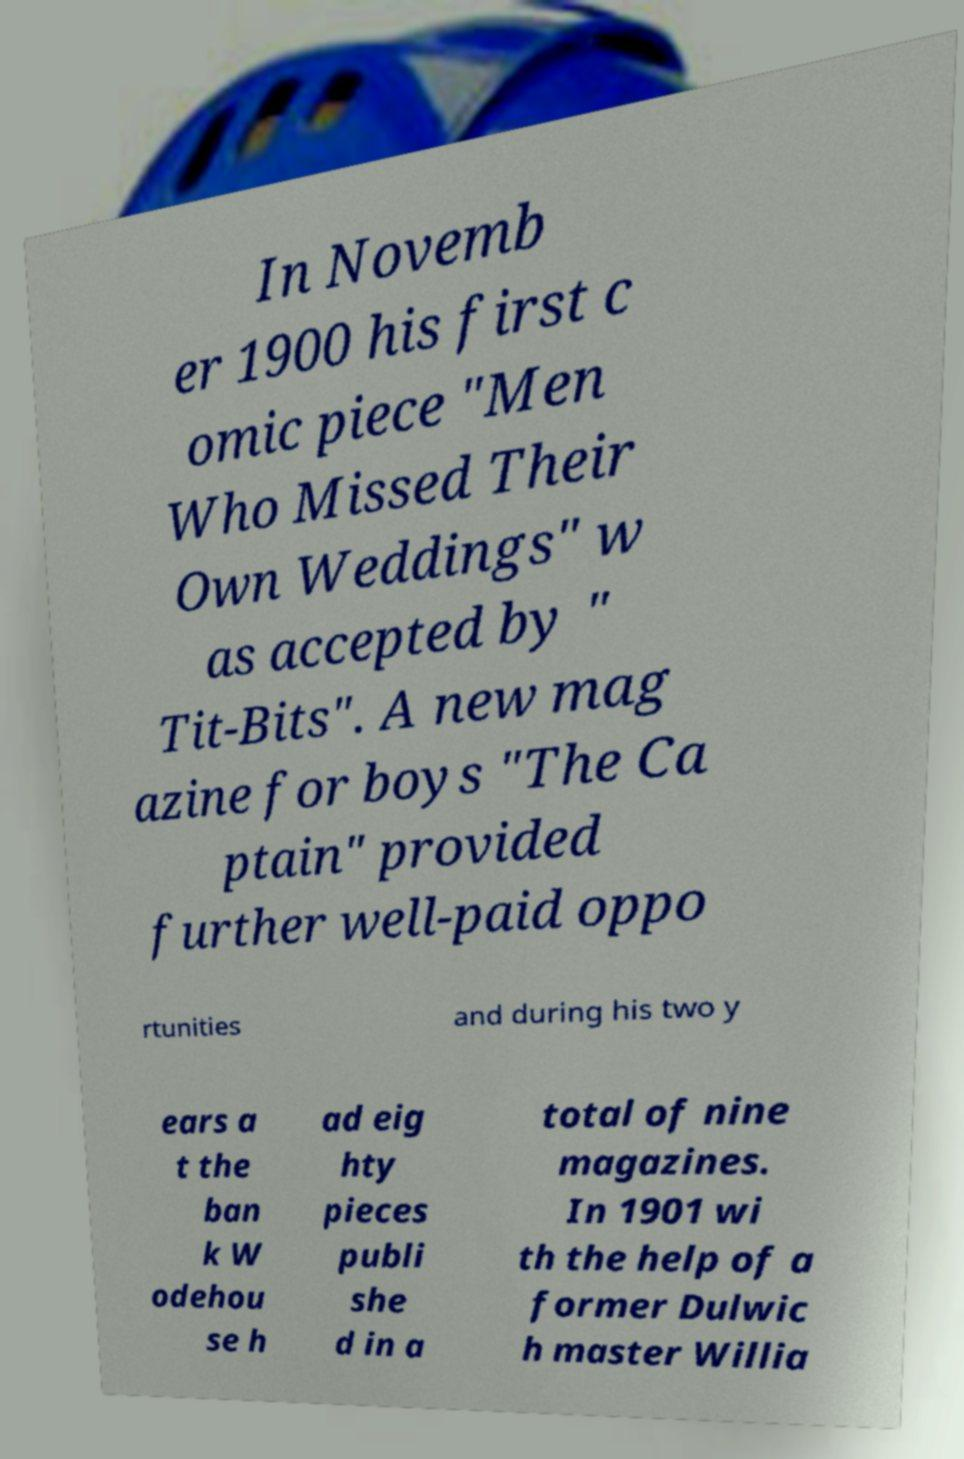I need the written content from this picture converted into text. Can you do that? In Novemb er 1900 his first c omic piece "Men Who Missed Their Own Weddings" w as accepted by " Tit-Bits". A new mag azine for boys "The Ca ptain" provided further well-paid oppo rtunities and during his two y ears a t the ban k W odehou se h ad eig hty pieces publi she d in a total of nine magazines. In 1901 wi th the help of a former Dulwic h master Willia 